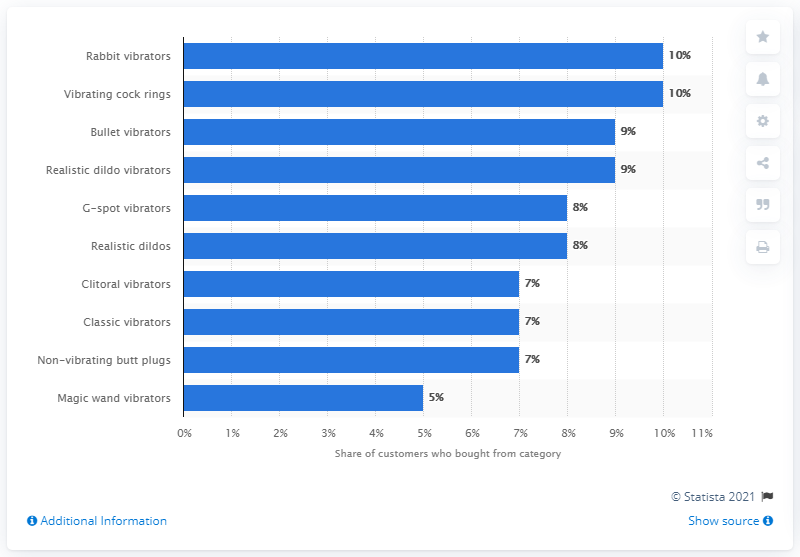Point out several critical features in this image. It is estimated that approximately 10% of UK customers have purchased cock rings and rabbit vibrators. 